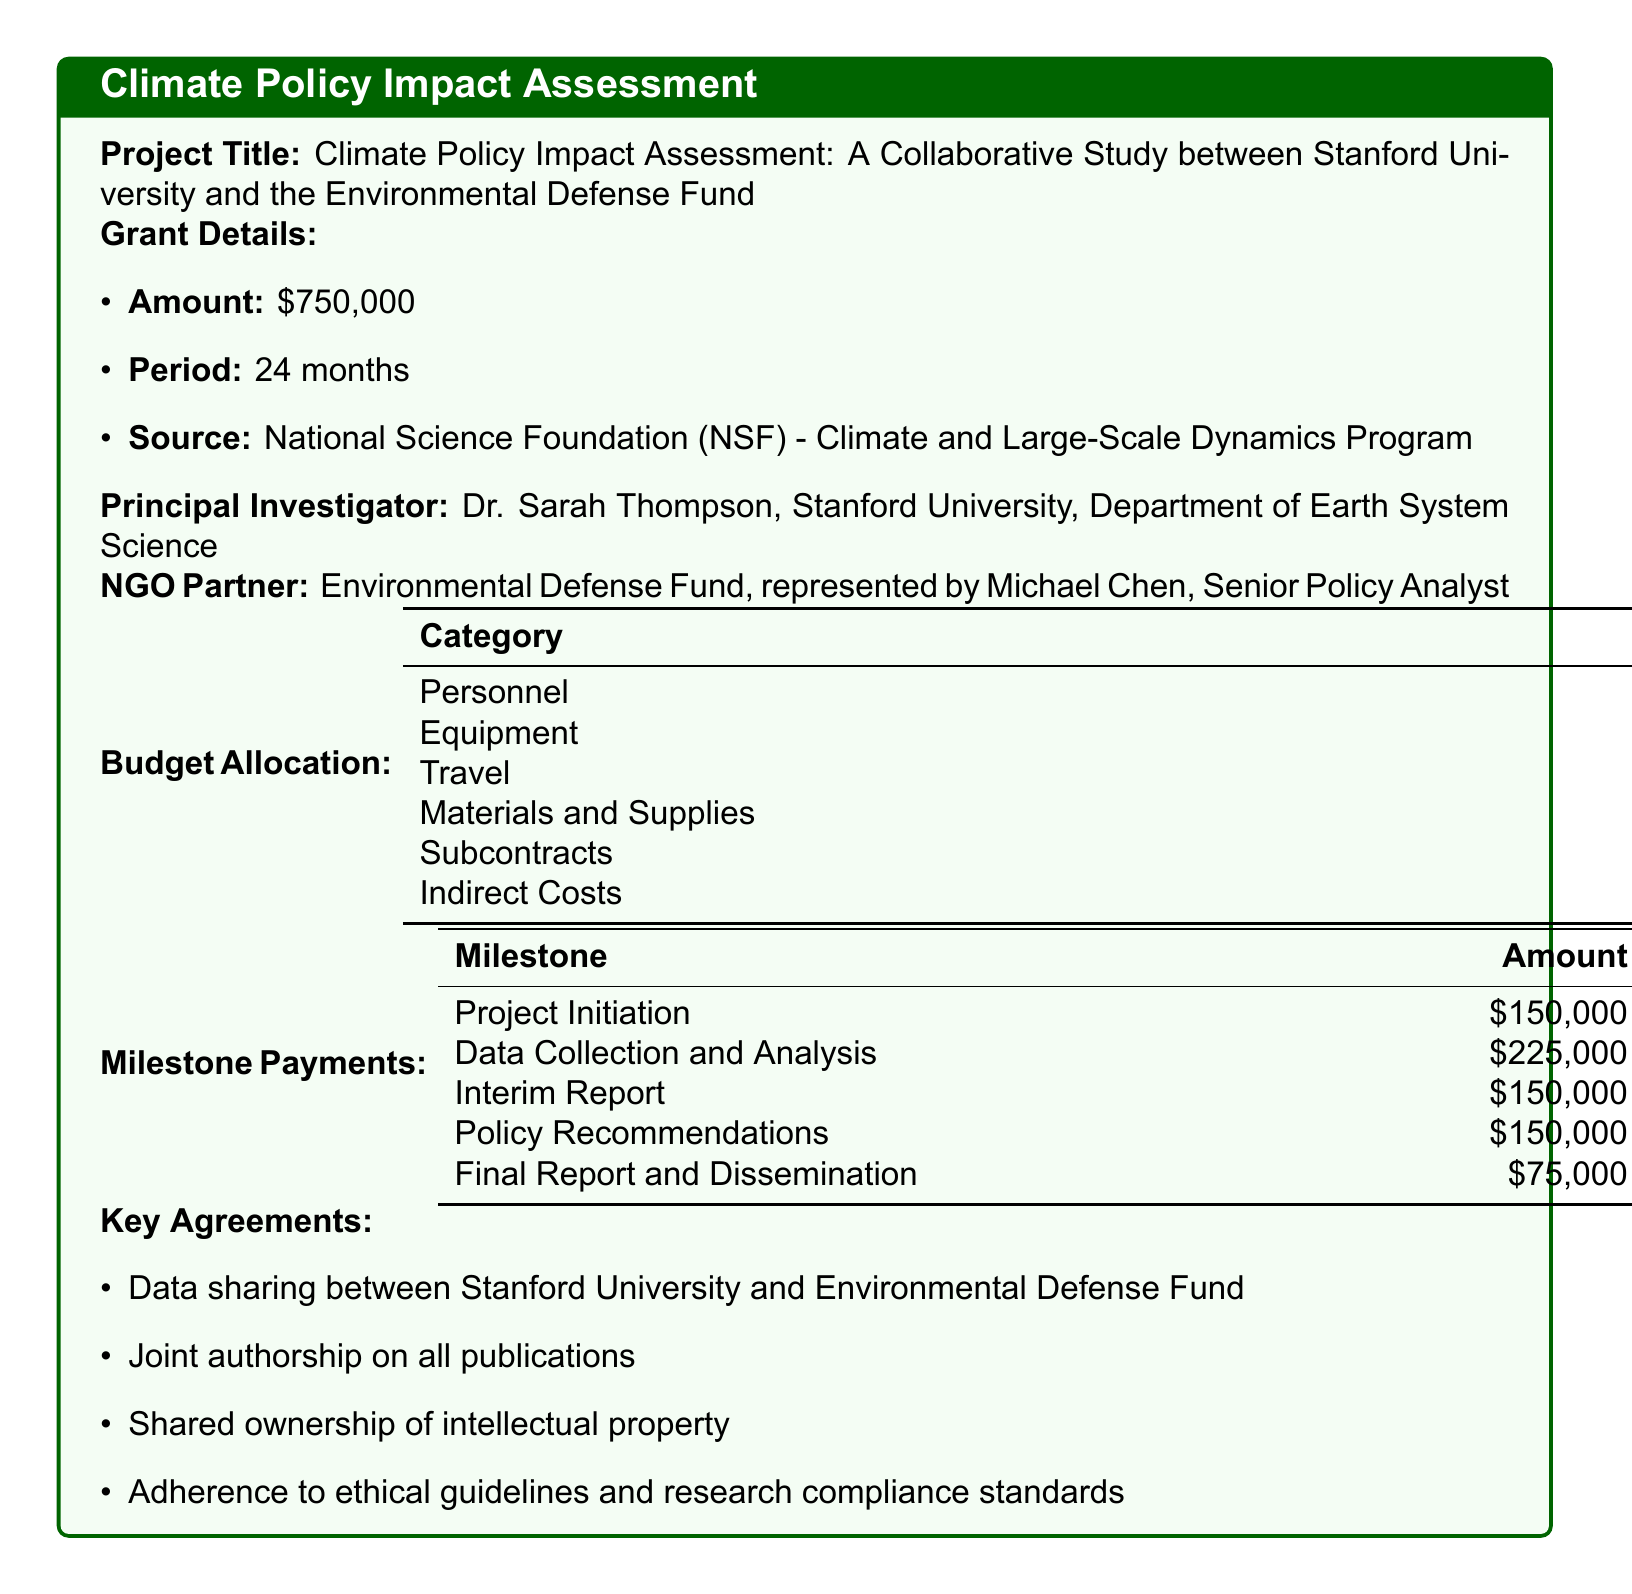What is the total grant amount? The total grant amount is stated at the beginning of the document, which is $750,000.
Answer: $750,000 Who is the principal investigator? The document identifies Dr. Sarah Thompson as the principal investigator for the project.
Answer: Dr. Sarah Thompson What is the budget allocation for Personnel? The budget allocation section lists the amount for Personnel as $450,000.
Answer: $450,000 When is the due date for the Interim Report milestone? The document specifies that the due date for the Interim Report milestone is September 1, 2024.
Answer: 2024-09-01 What category has the least budget allocation? By reviewing the budget allocation, the category with the least amount is Materials and Supplies, which has $30,000.
Answer: Materials and Supplies How many total milestones are listed in the document? The document enumerates a total of five milestones for this project.
Answer: 5 Which organization is responsible for the funding? The document indicates that the funding source is the National Science Foundation (NSF).
Answer: National Science Foundation (NSF) What are the reporting requirements for the project? The document lists the requirement for quarterly progress reports, annual financial statements, and a final project report.
Answer: Quarterly progress reports, annual financial statements, final project report What is the grant period for this project? The document specifies the grant period as 24 months.
Answer: 24 months 